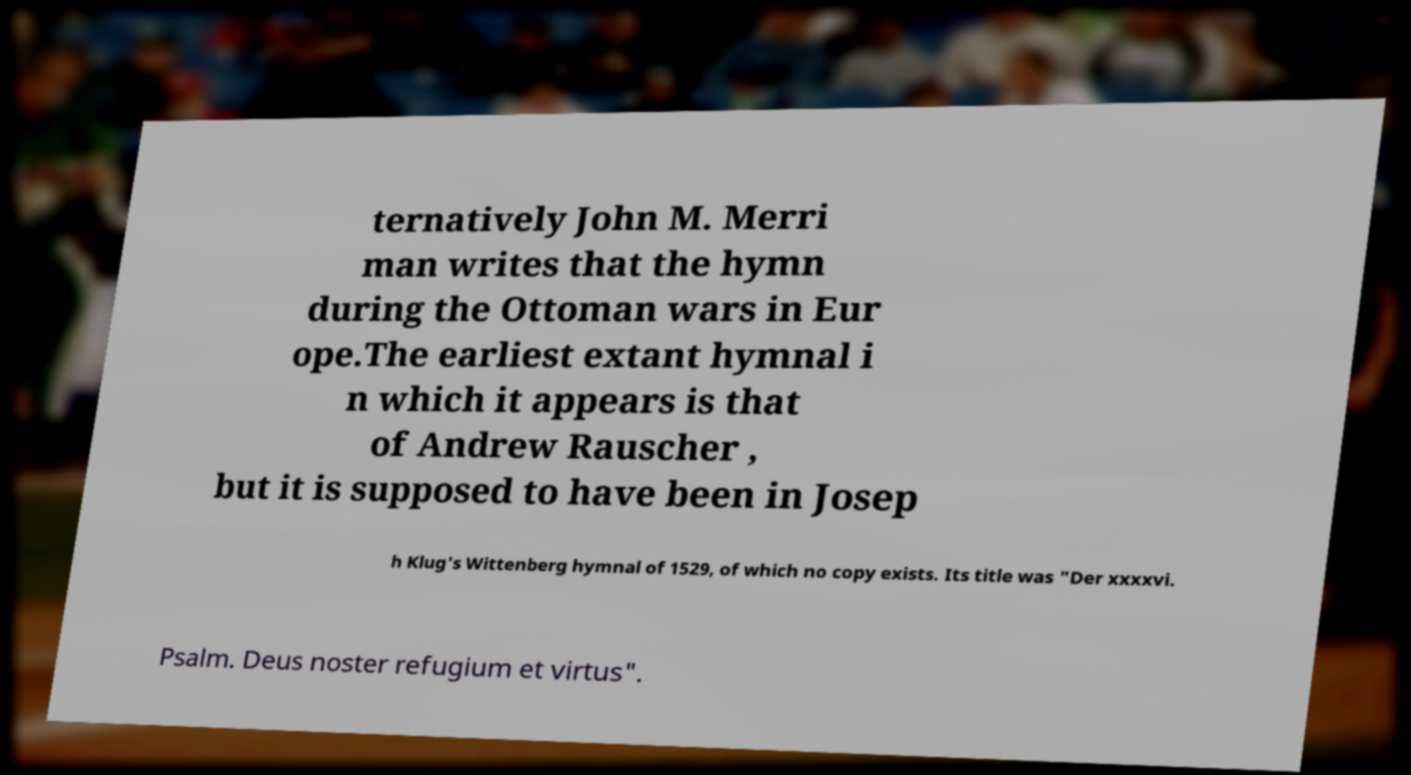Could you assist in decoding the text presented in this image and type it out clearly? ternatively John M. Merri man writes that the hymn during the Ottoman wars in Eur ope.The earliest extant hymnal i n which it appears is that of Andrew Rauscher , but it is supposed to have been in Josep h Klug's Wittenberg hymnal of 1529, of which no copy exists. Its title was "Der xxxxvi. Psalm. Deus noster refugium et virtus". 